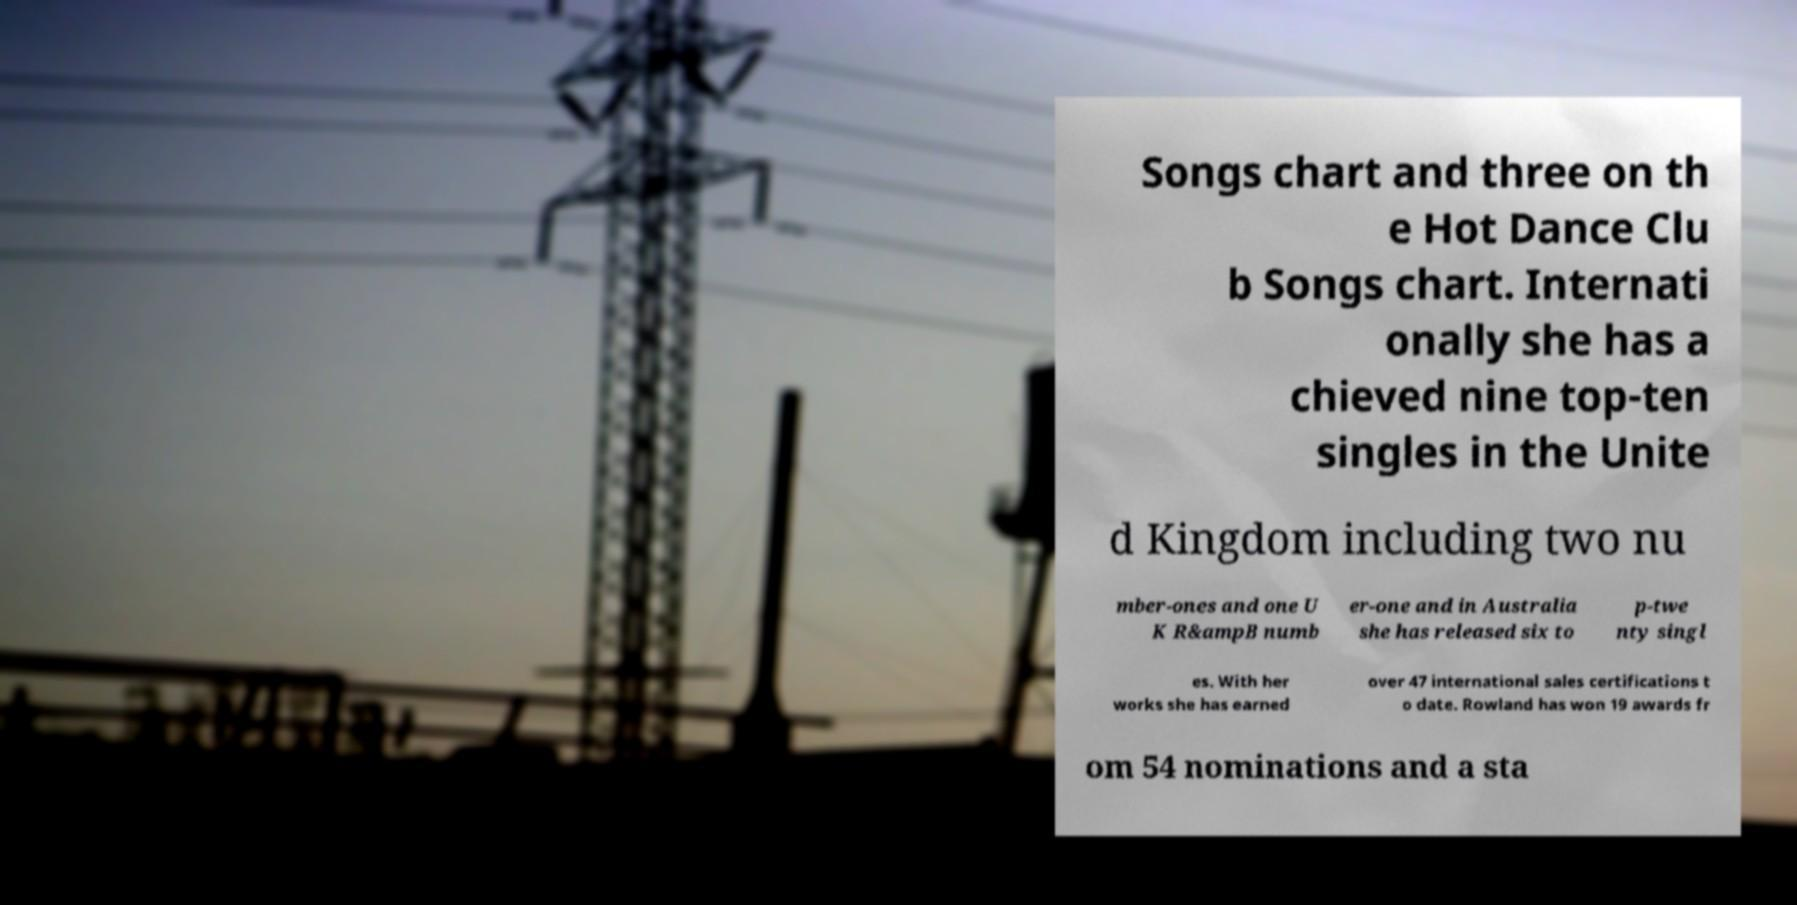Can you read and provide the text displayed in the image?This photo seems to have some interesting text. Can you extract and type it out for me? Songs chart and three on th e Hot Dance Clu b Songs chart. Internati onally she has a chieved nine top-ten singles in the Unite d Kingdom including two nu mber-ones and one U K R&ampB numb er-one and in Australia she has released six to p-twe nty singl es. With her works she has earned over 47 international sales certifications t o date. Rowland has won 19 awards fr om 54 nominations and a sta 